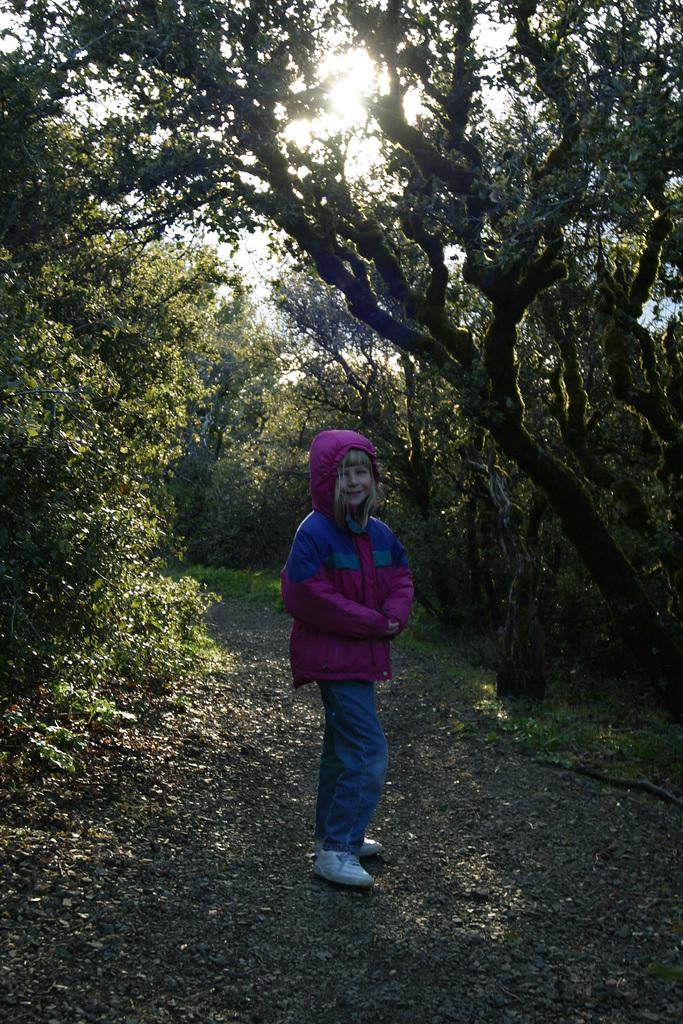What is the main subject of the image? The main subject of the image is a kid standing. What is the kid wearing in the image? The kid is wearing a purple coat and blue trousers. What can be seen in the background of the image? There are trees in the image. What type of hose is the kid holding in the image? There is no hose present in the image. Can you tell me how many cows are visible in the image? There are no cows visible in the image. 